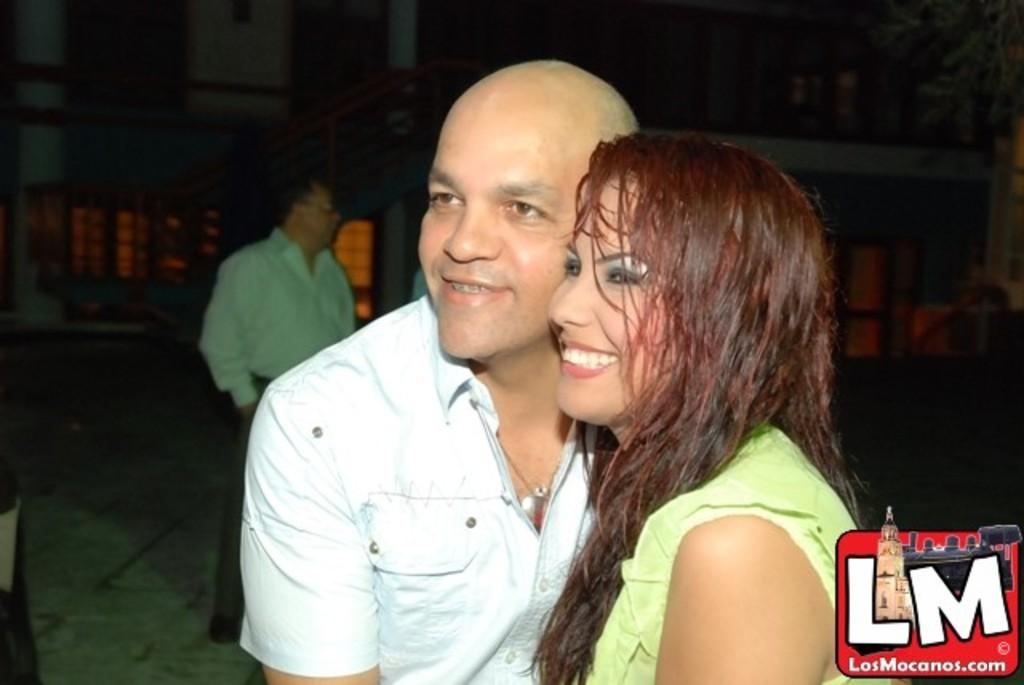Who or what can be seen in the image? There are people in the image. What type of structure is visible in the image? There is a building in the image. What feature can be seen near the people in the image? There is a railing in the image. What type of plant is present in the image? There is a tree in the image. Where is the logo located in the image? The logo is at the bottom right side of the image. How many clocks are visible in the image? There are no clocks present in the image. What type of steam is coming from the building in the image? There is no steam present in the image. 